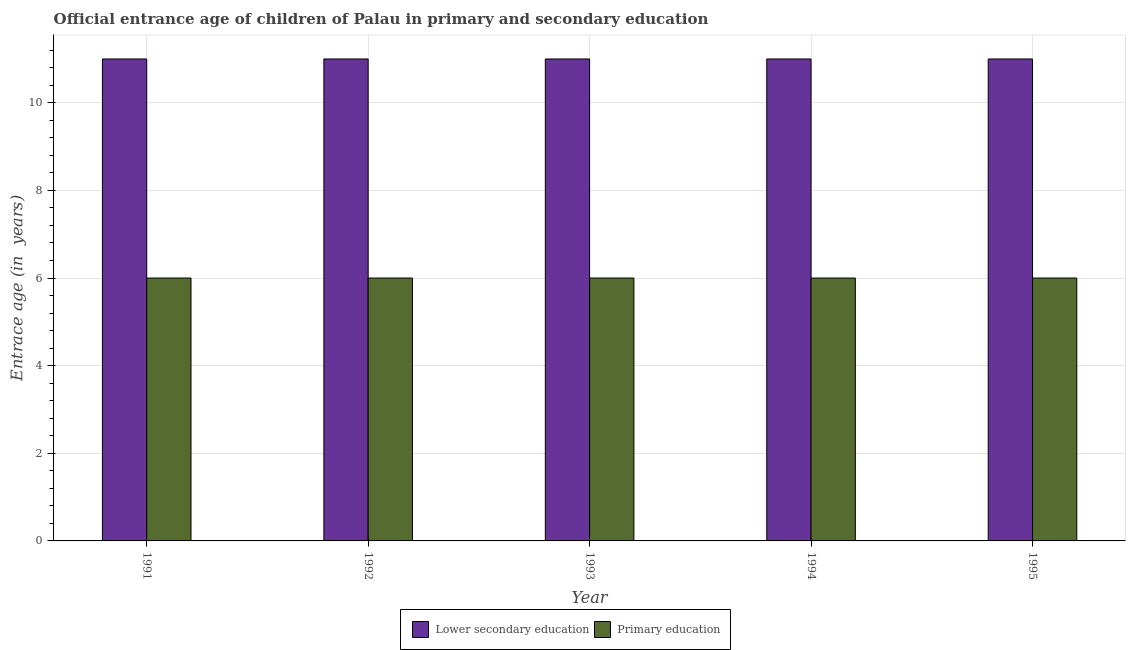How many different coloured bars are there?
Provide a short and direct response. 2. How many bars are there on the 5th tick from the right?
Offer a terse response. 2. What is the label of the 4th group of bars from the left?
Provide a succinct answer. 1994. In how many cases, is the number of bars for a given year not equal to the number of legend labels?
Provide a short and direct response. 0. Across all years, what is the minimum entrance age of children in lower secondary education?
Provide a succinct answer. 11. In which year was the entrance age of children in lower secondary education maximum?
Your answer should be very brief. 1991. What is the total entrance age of chiildren in primary education in the graph?
Offer a very short reply. 30. What is the average entrance age of children in lower secondary education per year?
Ensure brevity in your answer.  11. What is the ratio of the entrance age of chiildren in primary education in 1992 to that in 1995?
Your response must be concise. 1. Is the entrance age of chiildren in primary education in 1994 less than that in 1995?
Provide a short and direct response. No. Is the difference between the entrance age of chiildren in primary education in 1991 and 1995 greater than the difference between the entrance age of children in lower secondary education in 1991 and 1995?
Ensure brevity in your answer.  No. What is the difference between the highest and the lowest entrance age of chiildren in primary education?
Your answer should be compact. 0. Is the sum of the entrance age of chiildren in primary education in 1992 and 1995 greater than the maximum entrance age of children in lower secondary education across all years?
Your response must be concise. Yes. What does the 2nd bar from the left in 1995 represents?
Your answer should be compact. Primary education. What does the 1st bar from the right in 1995 represents?
Provide a succinct answer. Primary education. How many years are there in the graph?
Keep it short and to the point. 5. Are the values on the major ticks of Y-axis written in scientific E-notation?
Keep it short and to the point. No. How many legend labels are there?
Provide a succinct answer. 2. What is the title of the graph?
Provide a short and direct response. Official entrance age of children of Palau in primary and secondary education. Does "IMF concessional" appear as one of the legend labels in the graph?
Your response must be concise. No. What is the label or title of the Y-axis?
Your answer should be very brief. Entrace age (in  years). What is the Entrace age (in  years) of Lower secondary education in 1991?
Ensure brevity in your answer.  11. What is the Entrace age (in  years) in Primary education in 1991?
Offer a very short reply. 6. What is the Entrace age (in  years) of Lower secondary education in 1992?
Offer a very short reply. 11. What is the Entrace age (in  years) in Primary education in 1993?
Make the answer very short. 6. What is the total Entrace age (in  years) in Primary education in the graph?
Provide a short and direct response. 30. What is the difference between the Entrace age (in  years) in Lower secondary education in 1991 and that in 1992?
Provide a succinct answer. 0. What is the difference between the Entrace age (in  years) in Primary education in 1991 and that in 1992?
Provide a short and direct response. 0. What is the difference between the Entrace age (in  years) in Lower secondary education in 1991 and that in 1993?
Offer a terse response. 0. What is the difference between the Entrace age (in  years) of Lower secondary education in 1991 and that in 1994?
Give a very brief answer. 0. What is the difference between the Entrace age (in  years) of Primary education in 1991 and that in 1994?
Make the answer very short. 0. What is the difference between the Entrace age (in  years) in Lower secondary education in 1991 and that in 1995?
Your answer should be very brief. 0. What is the difference between the Entrace age (in  years) in Lower secondary education in 1992 and that in 1993?
Ensure brevity in your answer.  0. What is the difference between the Entrace age (in  years) in Primary education in 1992 and that in 1993?
Your answer should be compact. 0. What is the difference between the Entrace age (in  years) in Lower secondary education in 1992 and that in 1995?
Ensure brevity in your answer.  0. What is the difference between the Entrace age (in  years) in Primary education in 1993 and that in 1994?
Your response must be concise. 0. What is the difference between the Entrace age (in  years) in Lower secondary education in 1993 and that in 1995?
Provide a short and direct response. 0. What is the difference between the Entrace age (in  years) of Primary education in 1994 and that in 1995?
Your answer should be very brief. 0. What is the difference between the Entrace age (in  years) in Lower secondary education in 1991 and the Entrace age (in  years) in Primary education in 1992?
Your answer should be very brief. 5. What is the difference between the Entrace age (in  years) in Lower secondary education in 1991 and the Entrace age (in  years) in Primary education in 1993?
Offer a very short reply. 5. What is the difference between the Entrace age (in  years) of Lower secondary education in 1992 and the Entrace age (in  years) of Primary education in 1994?
Your response must be concise. 5. What is the difference between the Entrace age (in  years) in Lower secondary education in 1992 and the Entrace age (in  years) in Primary education in 1995?
Provide a succinct answer. 5. What is the average Entrace age (in  years) of Lower secondary education per year?
Provide a short and direct response. 11. What is the average Entrace age (in  years) of Primary education per year?
Make the answer very short. 6. In the year 1992, what is the difference between the Entrace age (in  years) of Lower secondary education and Entrace age (in  years) of Primary education?
Your answer should be very brief. 5. In the year 1993, what is the difference between the Entrace age (in  years) in Lower secondary education and Entrace age (in  years) in Primary education?
Offer a very short reply. 5. In the year 1995, what is the difference between the Entrace age (in  years) of Lower secondary education and Entrace age (in  years) of Primary education?
Your answer should be compact. 5. What is the ratio of the Entrace age (in  years) in Primary education in 1991 to that in 1992?
Provide a short and direct response. 1. What is the ratio of the Entrace age (in  years) of Lower secondary education in 1991 to that in 1993?
Offer a terse response. 1. What is the ratio of the Entrace age (in  years) in Primary education in 1991 to that in 1993?
Make the answer very short. 1. What is the ratio of the Entrace age (in  years) in Lower secondary education in 1991 to that in 1994?
Give a very brief answer. 1. What is the ratio of the Entrace age (in  years) in Lower secondary education in 1991 to that in 1995?
Offer a terse response. 1. What is the ratio of the Entrace age (in  years) in Primary education in 1991 to that in 1995?
Your answer should be very brief. 1. What is the ratio of the Entrace age (in  years) of Lower secondary education in 1992 to that in 1993?
Keep it short and to the point. 1. What is the ratio of the Entrace age (in  years) of Primary education in 1992 to that in 1993?
Give a very brief answer. 1. What is the ratio of the Entrace age (in  years) of Lower secondary education in 1992 to that in 1994?
Offer a terse response. 1. What is the ratio of the Entrace age (in  years) of Primary education in 1993 to that in 1994?
Ensure brevity in your answer.  1. What is the ratio of the Entrace age (in  years) of Lower secondary education in 1993 to that in 1995?
Make the answer very short. 1. What is the ratio of the Entrace age (in  years) of Primary education in 1993 to that in 1995?
Offer a terse response. 1. What is the difference between the highest and the second highest Entrace age (in  years) of Lower secondary education?
Your answer should be very brief. 0. What is the difference between the highest and the second highest Entrace age (in  years) of Primary education?
Give a very brief answer. 0. 